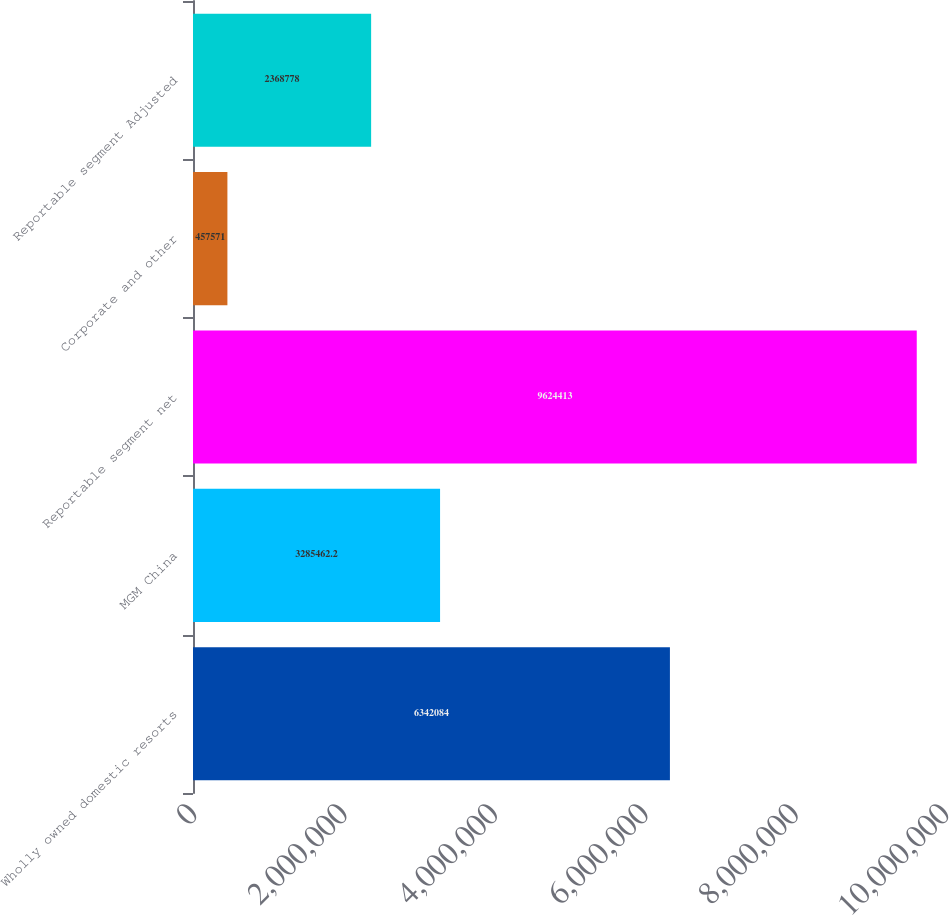<chart> <loc_0><loc_0><loc_500><loc_500><bar_chart><fcel>Wholly owned domestic resorts<fcel>MGM China<fcel>Reportable segment net<fcel>Corporate and other<fcel>Reportable segment Adjusted<nl><fcel>6.34208e+06<fcel>3.28546e+06<fcel>9.62441e+06<fcel>457571<fcel>2.36878e+06<nl></chart> 